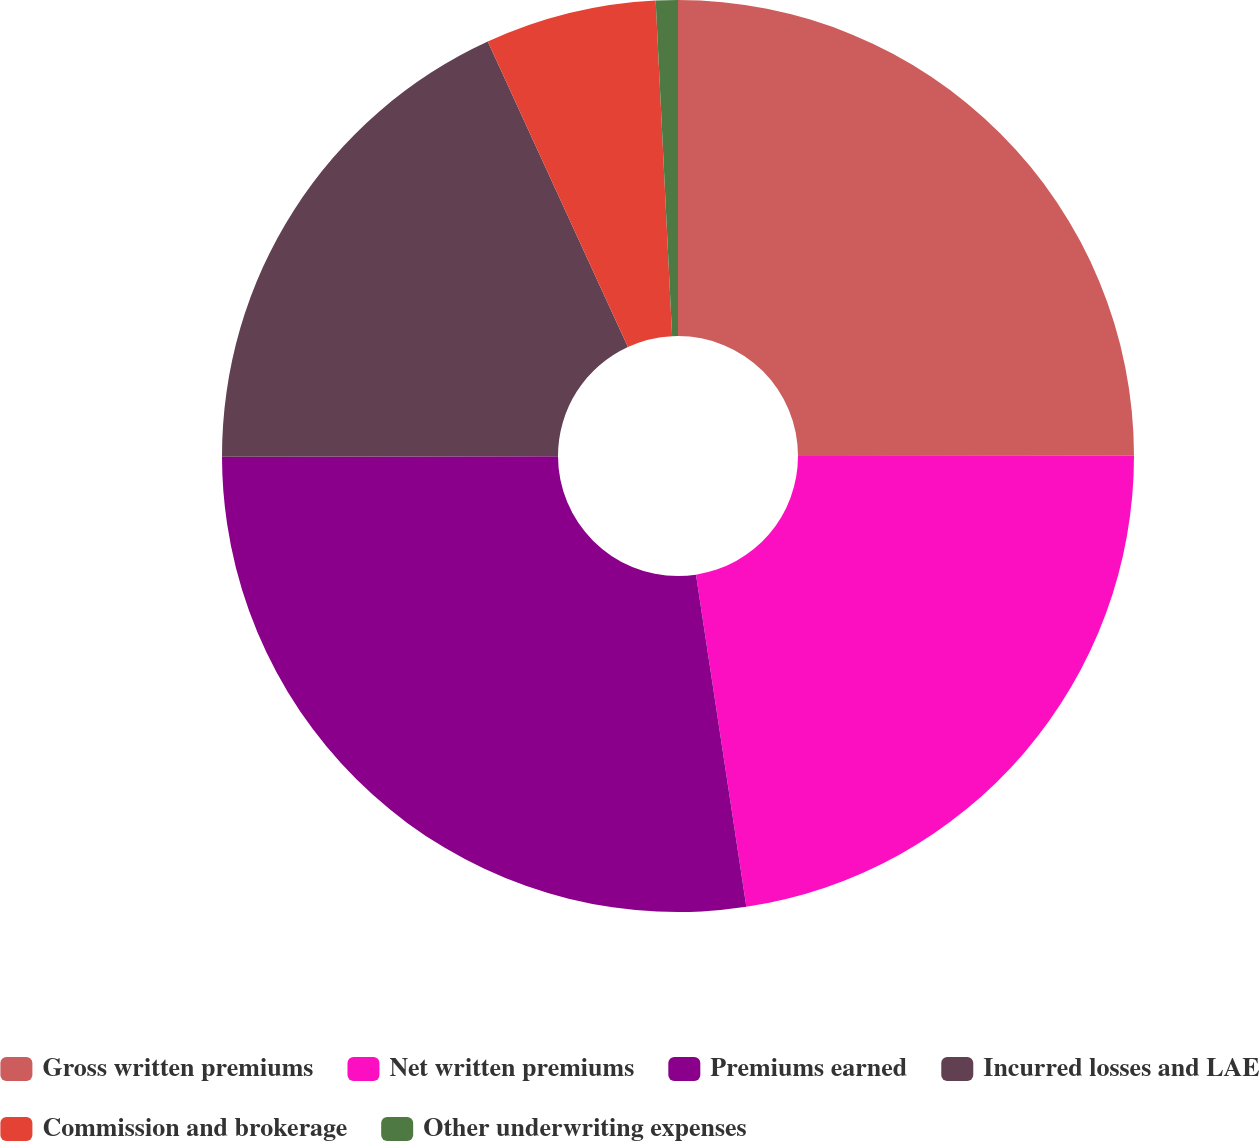Convert chart to OTSL. <chart><loc_0><loc_0><loc_500><loc_500><pie_chart><fcel>Gross written premiums<fcel>Net written premiums<fcel>Premiums earned<fcel>Incurred losses and LAE<fcel>Commission and brokerage<fcel>Other underwriting expenses<nl><fcel>24.99%<fcel>22.62%<fcel>27.37%<fcel>18.18%<fcel>6.07%<fcel>0.78%<nl></chart> 